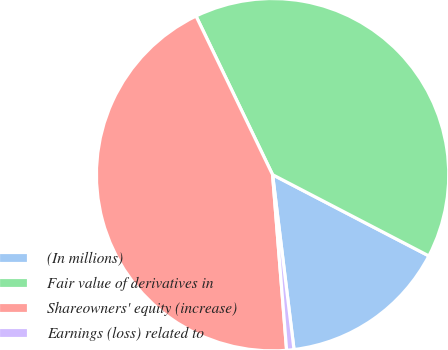Convert chart. <chart><loc_0><loc_0><loc_500><loc_500><pie_chart><fcel>(In millions)<fcel>Fair value of derivatives in<fcel>Shareowners' equity (increase)<fcel>Earnings (loss) related to<nl><fcel>15.43%<fcel>39.78%<fcel>44.11%<fcel>0.67%<nl></chart> 